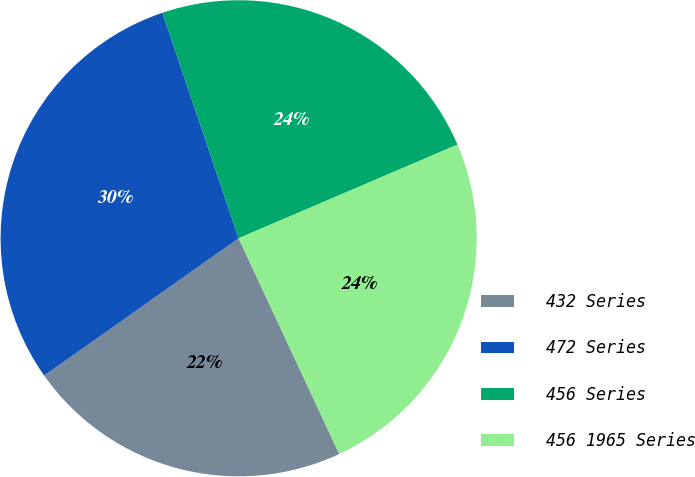Convert chart to OTSL. <chart><loc_0><loc_0><loc_500><loc_500><pie_chart><fcel>432 Series<fcel>472 Series<fcel>456 Series<fcel>456 1965 Series<nl><fcel>22.16%<fcel>29.6%<fcel>23.75%<fcel>24.49%<nl></chart> 